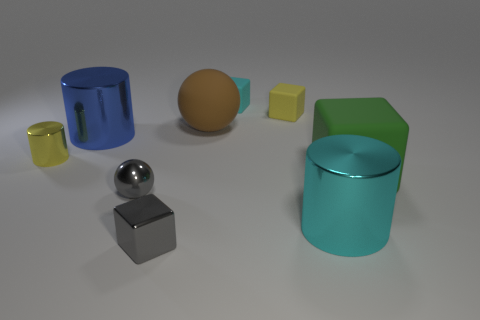Subtract all tiny cylinders. How many cylinders are left? 2 Subtract all cyan blocks. How many blocks are left? 3 Add 1 cyan metal things. How many objects exist? 10 Subtract all purple cylinders. Subtract all yellow cubes. How many cylinders are left? 3 Subtract all blocks. How many objects are left? 5 Subtract all large brown rubber things. Subtract all small purple shiny blocks. How many objects are left? 8 Add 1 brown rubber objects. How many brown rubber objects are left? 2 Add 4 small cubes. How many small cubes exist? 7 Subtract 1 brown spheres. How many objects are left? 8 